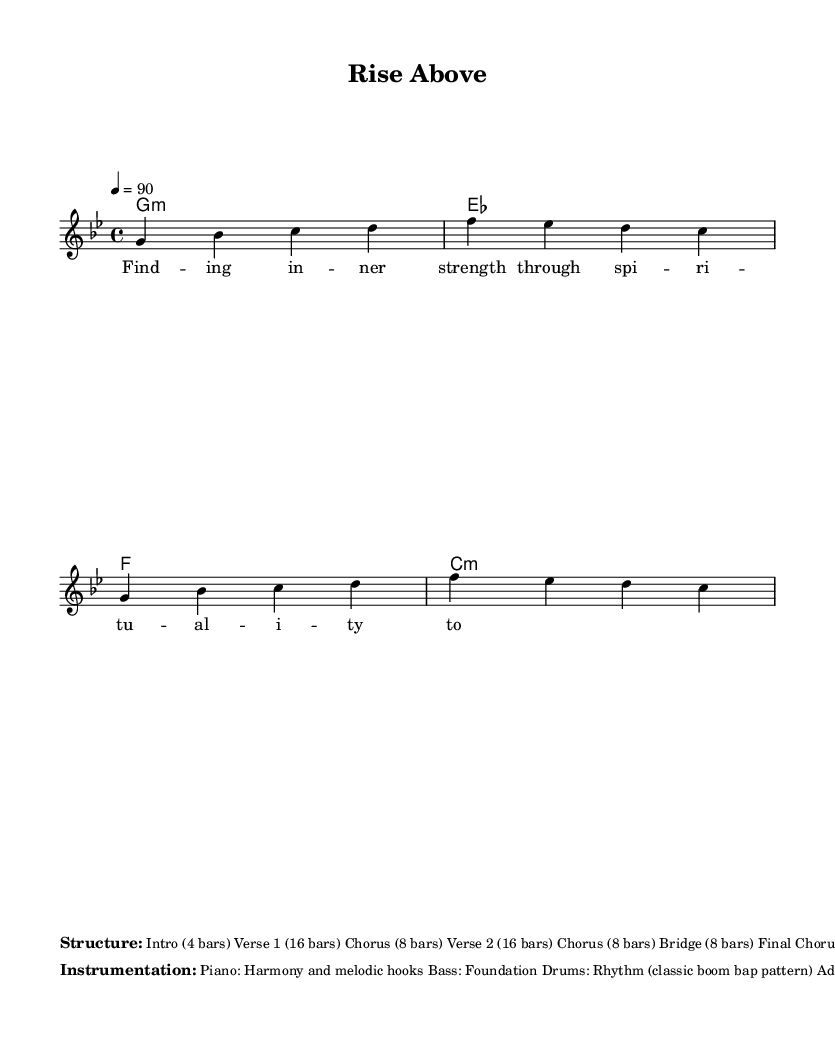What is the key signature of this music? The key signature is G minor, which contains two flats (B♭ and E♭). This can be determined by looking at the key signature symbol in the sheet music.
Answer: G minor What is the time signature of this piece? The time signature is 4/4, which means there are four beats in each measure and the quarter note gets one beat. This can be seen at the beginning of the staff notations, where the '4/4' is indicated.
Answer: 4/4 What is the tempo marking for the piece? The tempo marking is 90 BPM (beats per minute), which tells the performer the speed at which to play the music. It is noted in the tempo indication section of the sheet music.
Answer: 90 How many bars are in Verse 1? Verse 1 contains 16 bars, as specified in the structure of the piece listed in the markup section of the music. This tells us the length of this section of music.
Answer: 16 bars What instrumentation is used for the foundation of this track? The foundation is provided by the Bass, which is mentioned in the instrumentation description of the sheet music. The Bass is integral for grounding the harmonic structure.
Answer: Bass What type of sample is included in the additional instrumentation? Gospel choir samples are included as additional instrumentation, which emphasizes the uplifting and spiritual nature of the track, as described in the instrumentation section.
Answer: Gospel choir samples How many total sections are there in the structure of the piece? There are a total of 8 sections listed in the markup structure (Intro, Verse 1, Chorus, Verse 2, Chorus, Bridge, Final Chorus, Outro). By counting all the individual segments, we can find the total number of sections.
Answer: 8 sections 